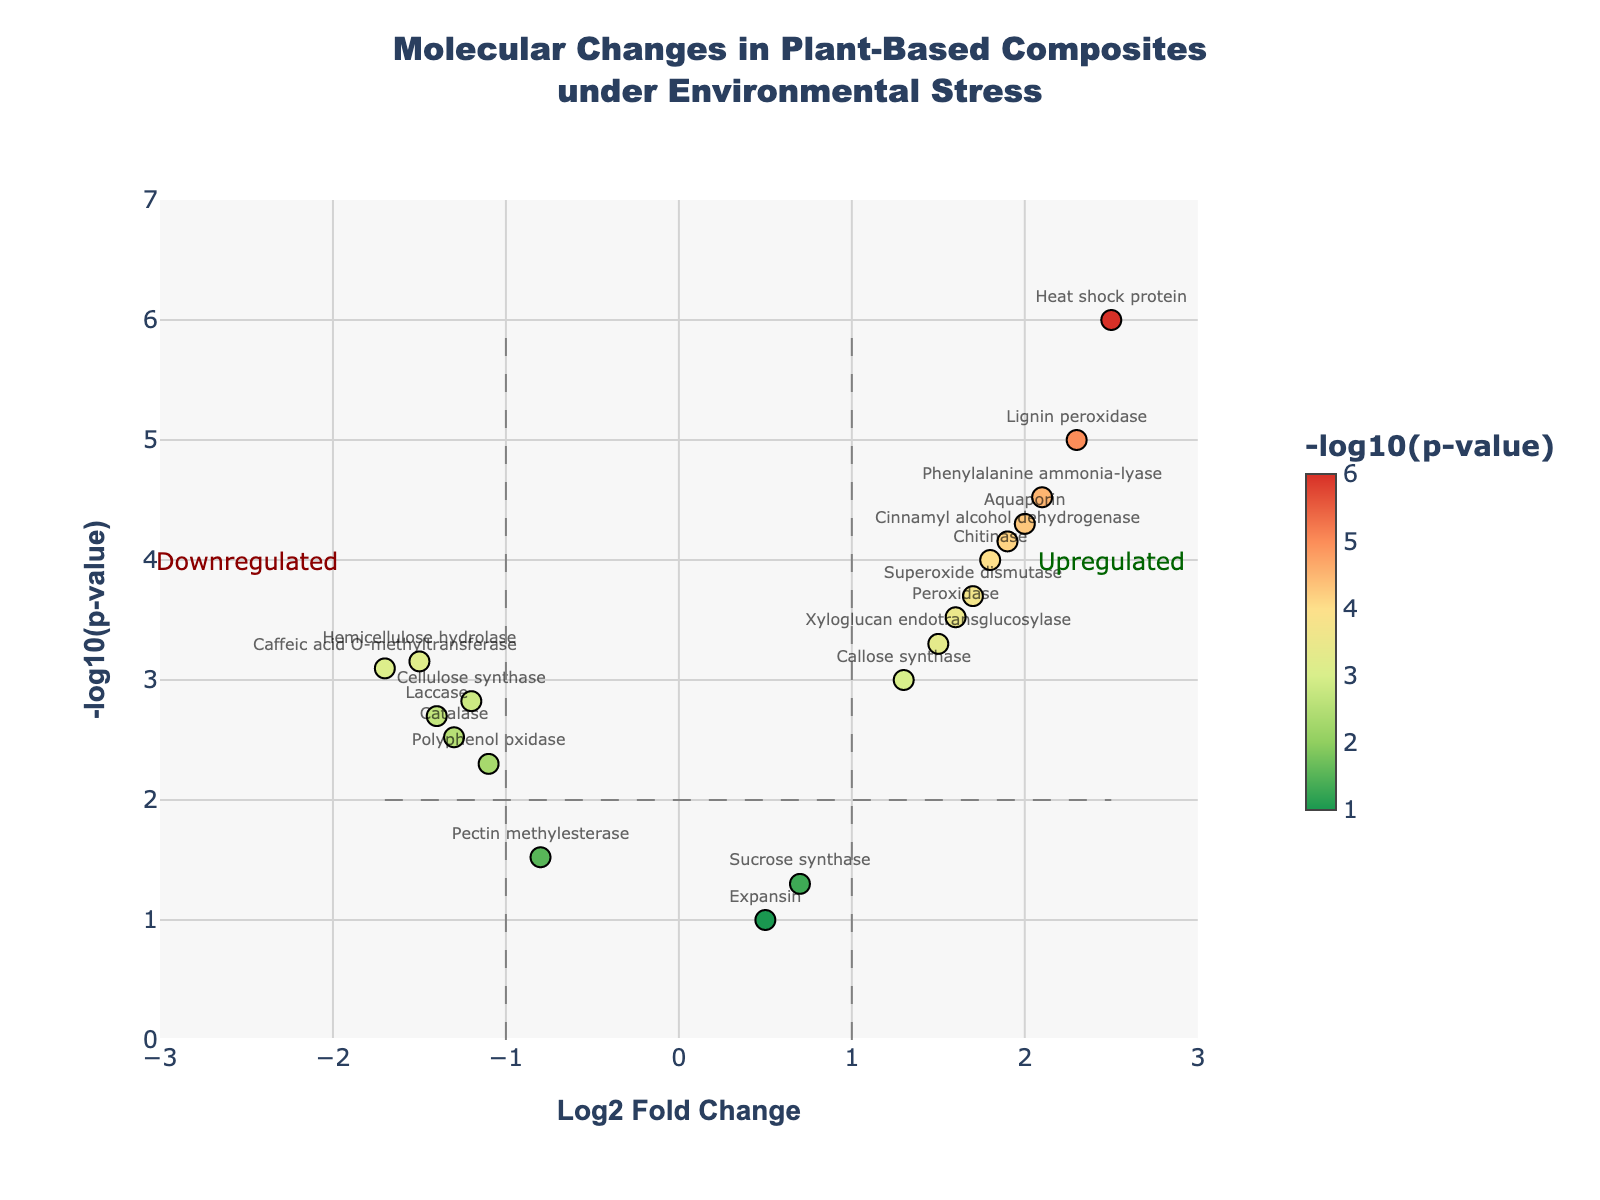What is the title of the plot? The title is found at the top of the plot. It should provide an overview of what the plot is showing.
Answer: Molecular Changes in Plant-Based Composites under Environmental Stress How many genes have a Log2 Fold Change greater than 2? Count the number of points with Log2 Fold Change values greater than 2 along the x-axis.
Answer: 2 Which gene has the highest -log10(p-value)? Find the gene corresponding to the highest y-axis value.
Answer: Heat shock protein What color represents higher -log10(p-value) values? Look at the color scale and identify the color at the upper end of the scale.
Answer: Darker red How many genes are significantly upregulated? Count the points in the right half of the plot (Log2 Fold Change > 1) that are above the significance threshold (horizontal line at y=2).
Answer: 7 Which downregulated gene has the lowest p-value? Among the points with negative Log2 Fold Change, find the one with the highest -log10(p-value).
Answer: Caffeic acid O-methyltransferase What is the average -log10(p-value) for upregulated genes? Find all points with positive Log2 Fold Change, sum their -log10(p-value) values, and divide by the number of such points.
Answer: (log10(0.00001)+log10(0.0005)+...)/count(upregulated) What is the range of Log2 Fold Change values shown in the plot? Look at the minimum and maximum values on the x-axis.
Answer: -3 to 3 Compare the -log10(p-value) of Lignin peroxidase and Aquaporin. Which one is higher? Locate both genes on the plot and compare their y-axis values.
Answer: Lignin peroxidase Which gene near Log2 Fold Change of 0 is not significant? Look for a point near the center with a low -log10(p-value), below the significance threshold.
Answer: Expansin 